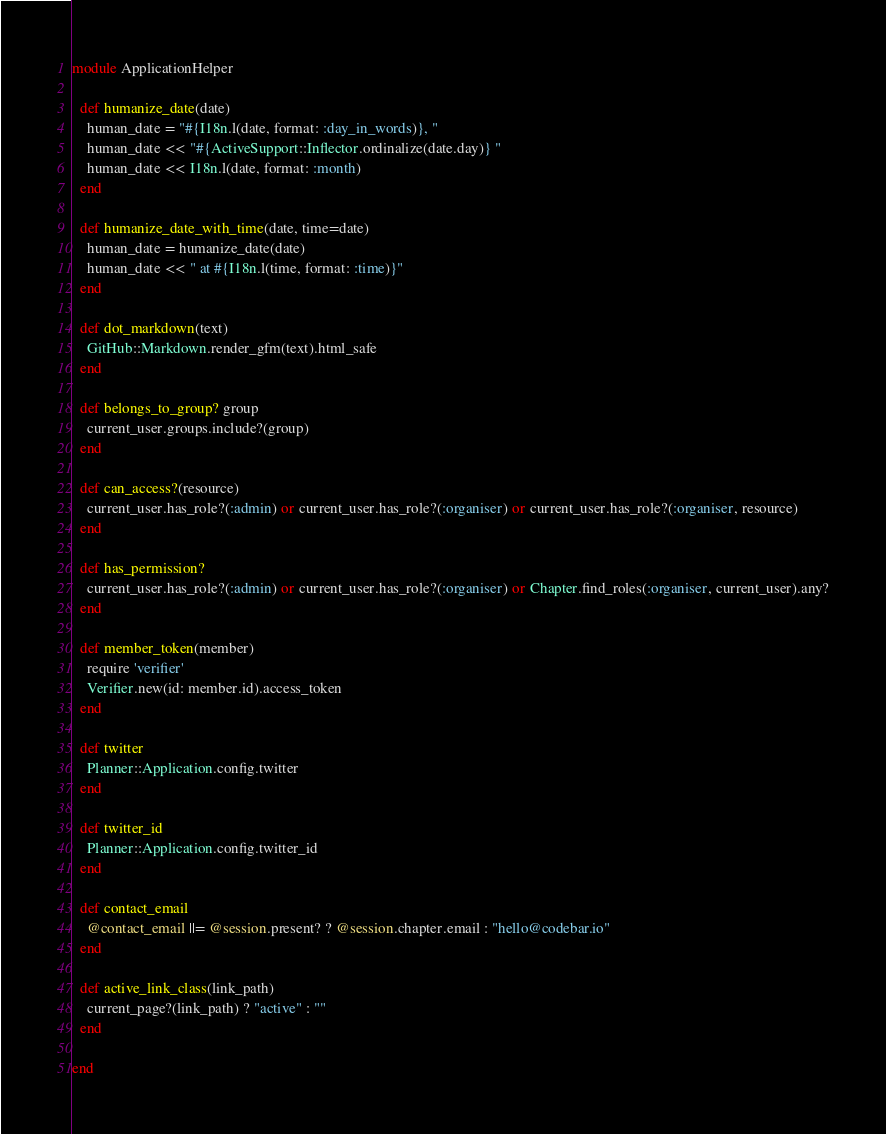Convert code to text. <code><loc_0><loc_0><loc_500><loc_500><_Ruby_>module ApplicationHelper

  def humanize_date(date)
    human_date = "#{I18n.l(date, format: :day_in_words)}, "
    human_date << "#{ActiveSupport::Inflector.ordinalize(date.day)} "
    human_date << I18n.l(date, format: :month)
  end

  def humanize_date_with_time(date, time=date)
    human_date = humanize_date(date)
    human_date << " at #{I18n.l(time, format: :time)}"
  end

  def dot_markdown(text)
    GitHub::Markdown.render_gfm(text).html_safe
  end

  def belongs_to_group? group
    current_user.groups.include?(group)
  end

  def can_access?(resource)
    current_user.has_role?(:admin) or current_user.has_role?(:organiser) or current_user.has_role?(:organiser, resource)
  end

  def has_permission?
    current_user.has_role?(:admin) or current_user.has_role?(:organiser) or Chapter.find_roles(:organiser, current_user).any?
  end

  def member_token(member)
    require 'verifier'
    Verifier.new(id: member.id).access_token
  end

  def twitter
    Planner::Application.config.twitter
  end

  def twitter_id
    Planner::Application.config.twitter_id
  end

  def contact_email
    @contact_email ||= @session.present? ? @session.chapter.email : "hello@codebar.io"
  end

  def active_link_class(link_path)
    current_page?(link_path) ? "active" : ""
  end

end
</code> 